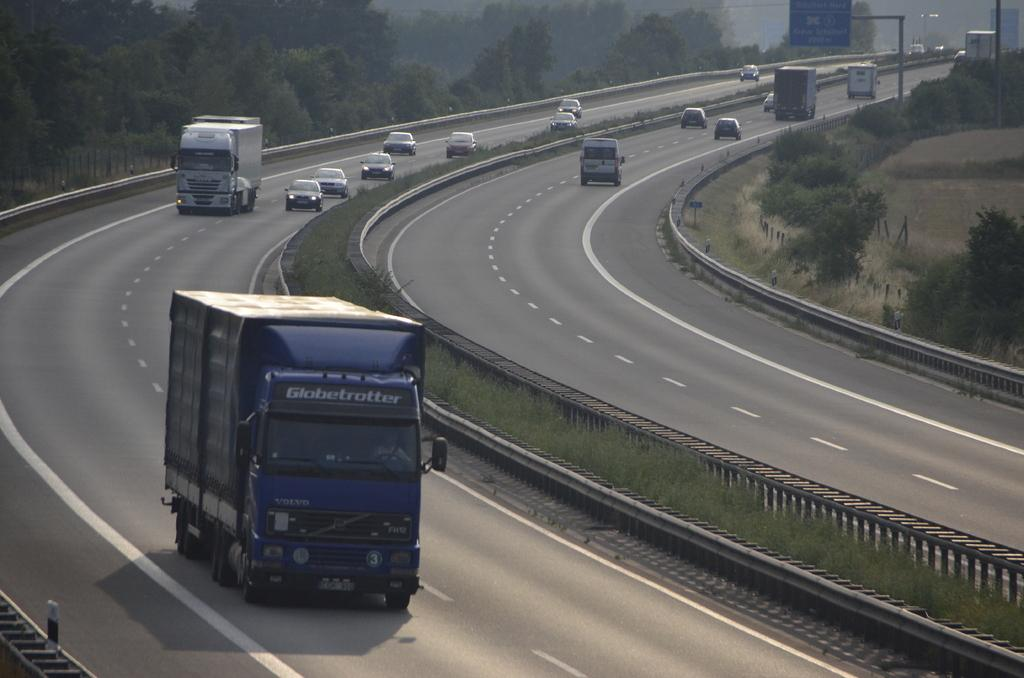What can be seen on the roads in the image? There are vehicles on the roads in the image. What is visible in the background of the image? There are trees, plants, a fence, poles, and other objects in the background of the image. Can you describe the natural elements in the background of the image? The natural elements in the background include trees and plants. What type of substance is being emitted from the vehicles in the image? There is no indication of any substance being emitted from the vehicles in the image. What kind of noise can be heard coming from the vehicles in the image? The image is silent, so no noise can be heard from the vehicles. 